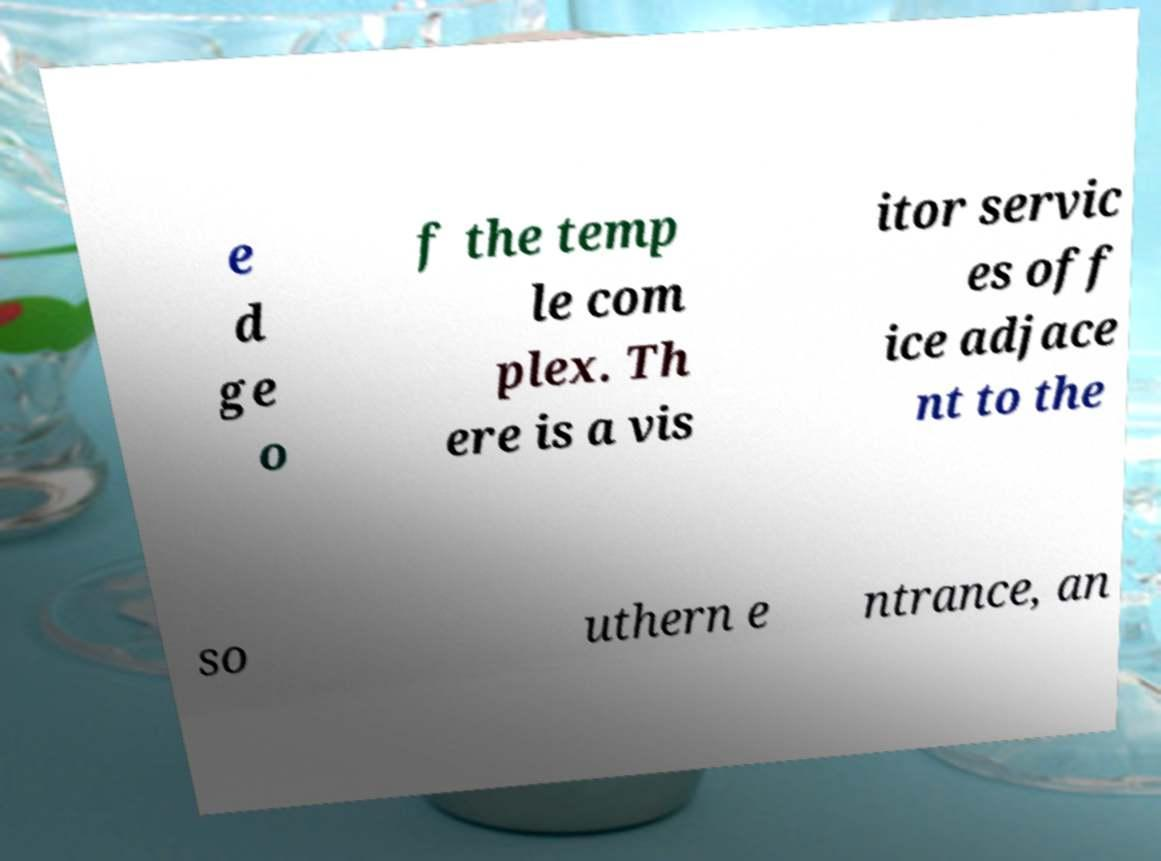What messages or text are displayed in this image? I need them in a readable, typed format. e d ge o f the temp le com plex. Th ere is a vis itor servic es off ice adjace nt to the so uthern e ntrance, an 